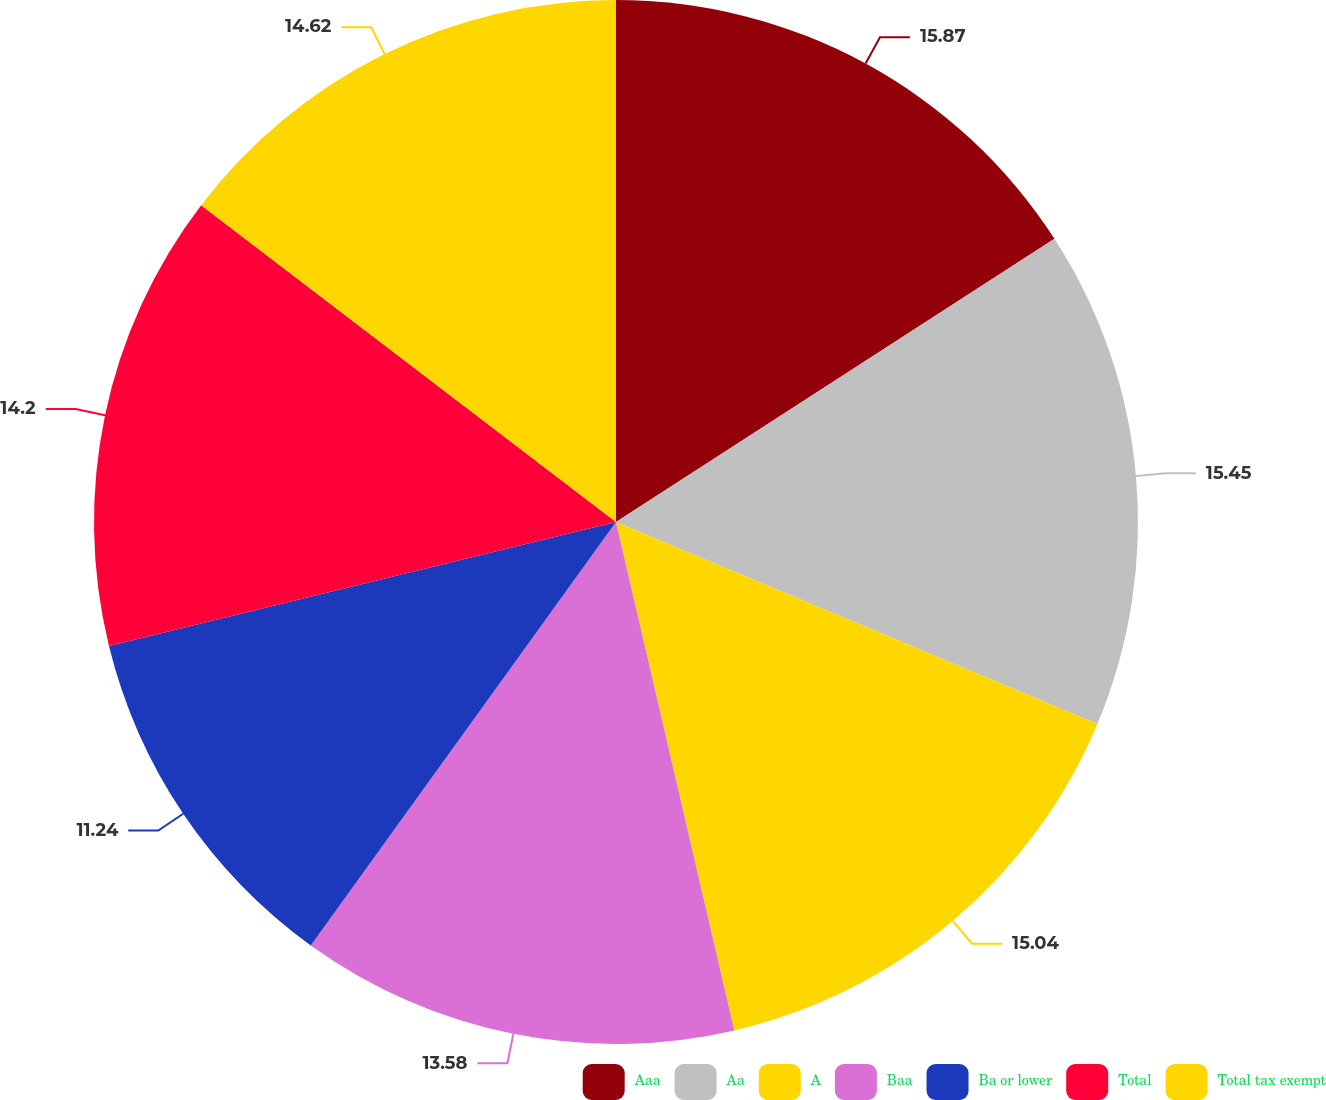<chart> <loc_0><loc_0><loc_500><loc_500><pie_chart><fcel>Aaa<fcel>Aa<fcel>A<fcel>Baa<fcel>Ba or lower<fcel>Total<fcel>Total tax exempt<nl><fcel>15.87%<fcel>15.45%<fcel>15.04%<fcel>13.58%<fcel>11.24%<fcel>14.2%<fcel>14.62%<nl></chart> 